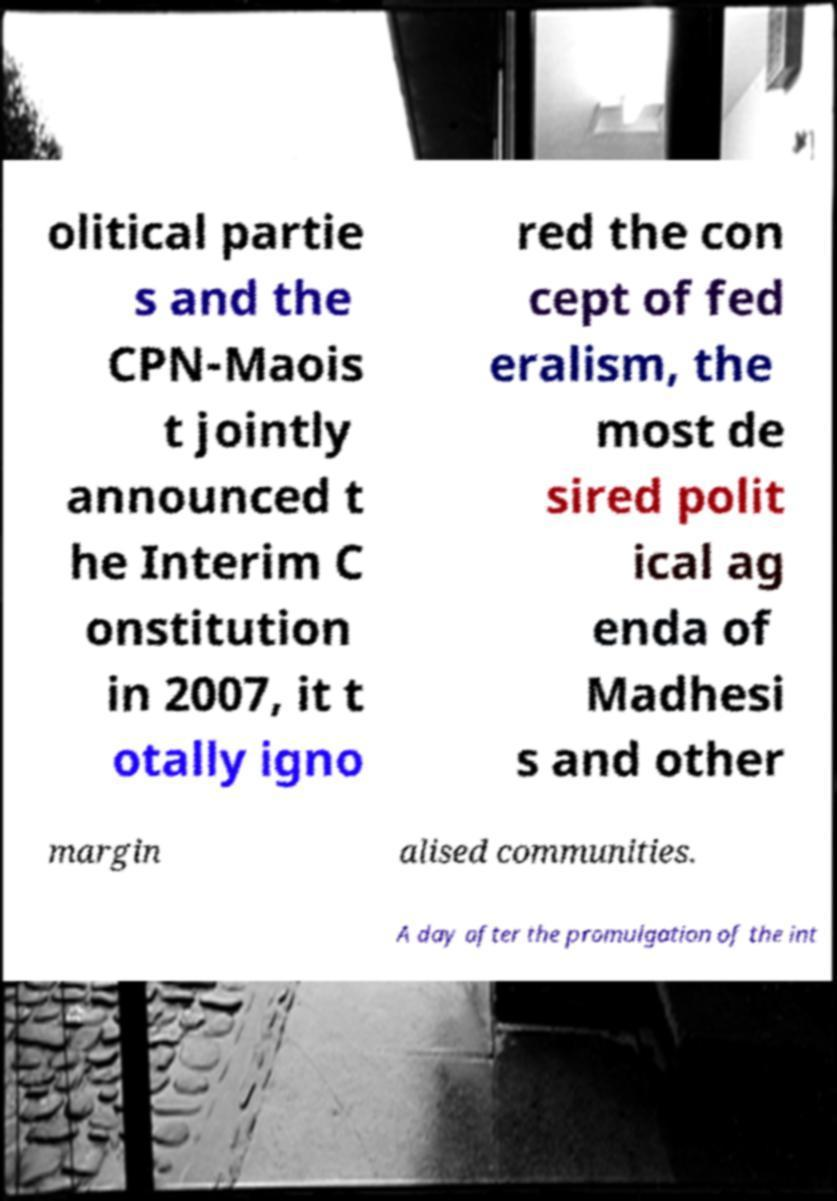Can you accurately transcribe the text from the provided image for me? olitical partie s and the CPN-Maois t jointly announced t he Interim C onstitution in 2007, it t otally igno red the con cept of fed eralism, the most de sired polit ical ag enda of Madhesi s and other margin alised communities. A day after the promulgation of the int 